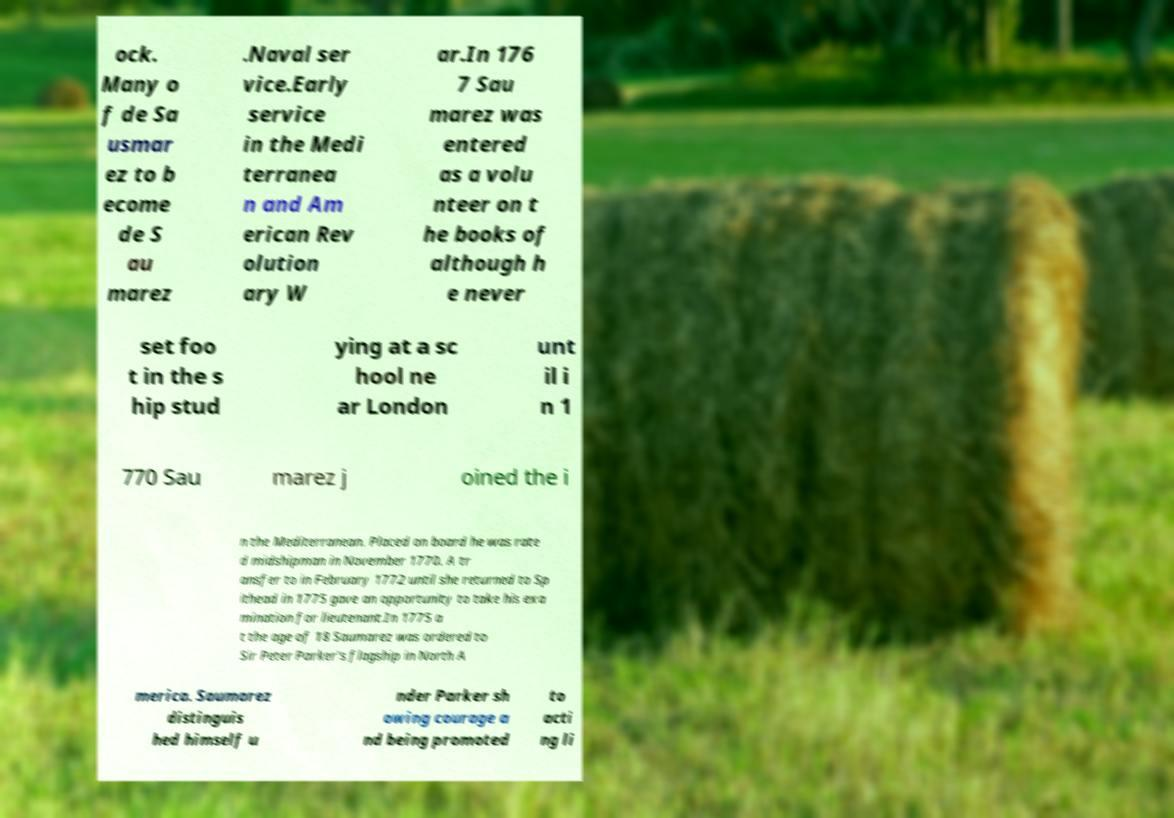Please read and relay the text visible in this image. What does it say? ock. Many o f de Sa usmar ez to b ecome de S au marez .Naval ser vice.Early service in the Medi terranea n and Am erican Rev olution ary W ar.In 176 7 Sau marez was entered as a volu nteer on t he books of although h e never set foo t in the s hip stud ying at a sc hool ne ar London unt il i n 1 770 Sau marez j oined the i n the Mediterranean. Placed on board he was rate d midshipman in November 1770. A tr ansfer to in February 1772 until she returned to Sp ithead in 1775 gave an opportunity to take his exa mination for lieutenant.In 1775 a t the age of 18 Saumarez was ordered to Sir Peter Parker's flagship in North A merica. Saumarez distinguis hed himself u nder Parker sh owing courage a nd being promoted to acti ng li 